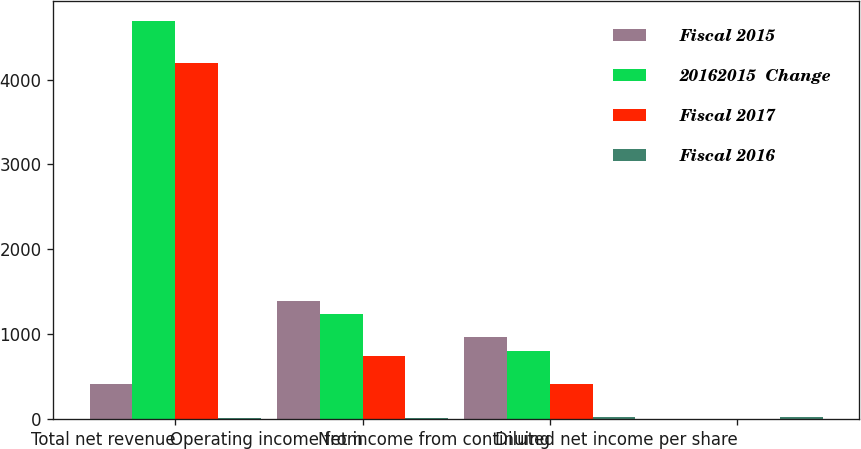Convert chart. <chart><loc_0><loc_0><loc_500><loc_500><stacked_bar_chart><ecel><fcel>Total net revenue<fcel>Operating income from<fcel>Net income from continuing<fcel>Diluted net income per share<nl><fcel>Fiscal 2015<fcel>413<fcel>1395<fcel>971<fcel>3.72<nl><fcel>20162015  Change<fcel>4694<fcel>1242<fcel>806<fcel>3.04<nl><fcel>Fiscal 2017<fcel>4192<fcel>738<fcel>413<fcel>1.45<nl><fcel>Fiscal 2016<fcel>10<fcel>12<fcel>20<fcel>22<nl></chart> 